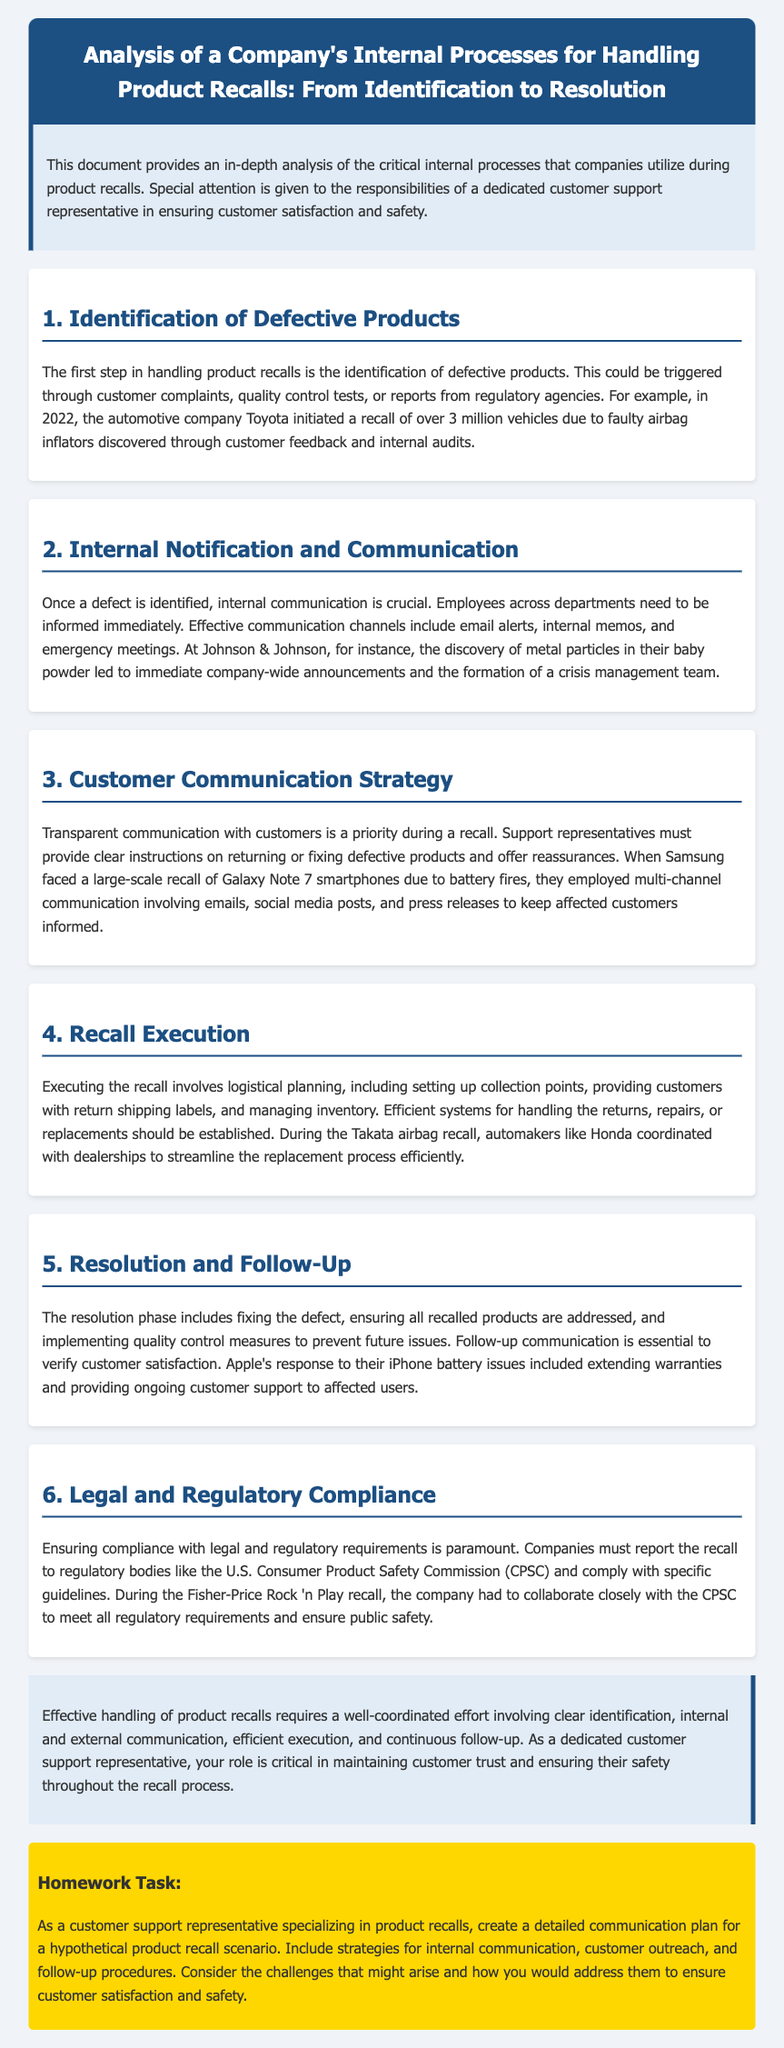What is the first step in handling product recalls? The first step in handling product recalls is the identification of defective products.
Answer: identification of defective products Which company initiated a recall of over 3 million vehicles in 2022? In 2022, the automotive company Toyota initiated a recall of over 3 million vehicles.
Answer: Toyota What communication method was used at Johnson & Johnson following a product defect discovery? At Johnson & Johnson, the discovery of metal particles led to immediate company-wide announcements.
Answer: company-wide announcements What was employed by Samsung to communicate about the Galaxy Note 7 recall? They employed multi-channel communication involving emails, social media posts, and press releases.
Answer: multi-channel communication What does the conclusion emphasize about the role of a customer support representative? The conclusion emphasizes the critical role of customer support representatives in maintaining customer trust and ensuring safety.
Answer: maintaining customer trust and ensuring safety In the Resolution and Follow-Up section, what does it state about ensuring customer satisfaction? Follow-up communication is essential to verify customer satisfaction.
Answer: Follow-up communication is essential What regulatory body must companies report recalls to? Companies must report the recall to regulatory bodies like the U.S. Consumer Product Safety Commission.
Answer: U.S. Consumer Product Safety Commission What was a suggested task for customer support representatives in the document? Create a detailed communication plan for a hypothetical product recall scenario.
Answer: Create a detailed communication plan 